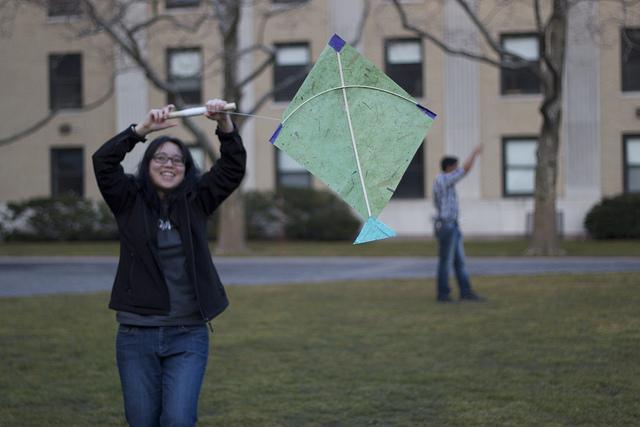What does she have in her right hand?
Be succinct. Kite. What is the little girl doing?
Quick response, please. Flying kite. How many chimneys are visible?
Write a very short answer. 0. Is this a current photo?
Write a very short answer. Yes. What color is the kite?
Keep it brief. Green. Are they walking through a park?
Be succinct. Yes. How many windows?
Be succinct. 12. Is this person skateboarding?
Quick response, please. No. What is in her hand?
Be succinct. Kite. Does the woman know how to fly a kite?
Keep it brief. Yes. Does the man have a bag?
Give a very brief answer. No. What is the woman holding in her hand?
Answer briefly. Kite. 